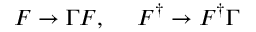<formula> <loc_0><loc_0><loc_500><loc_500>F \rightarrow \Gamma F , \quad F ^ { \dagger } \rightarrow F ^ { \dagger } \Gamma</formula> 